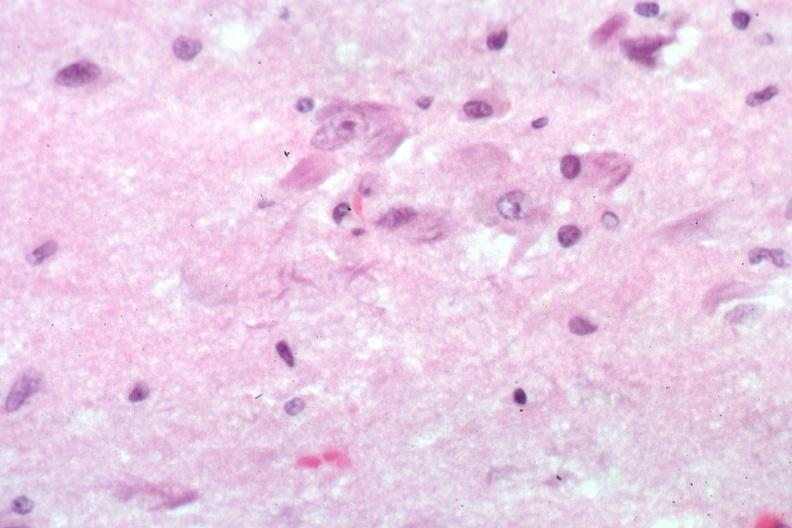what is present?
Answer the question using a single word or phrase. Brain 